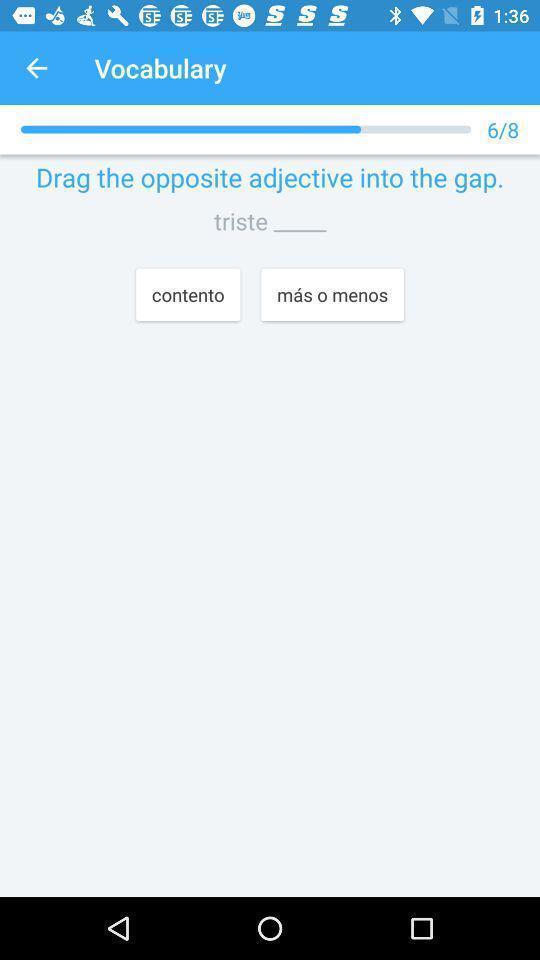What is the overall content of this screenshot? Screen page of learning application. 